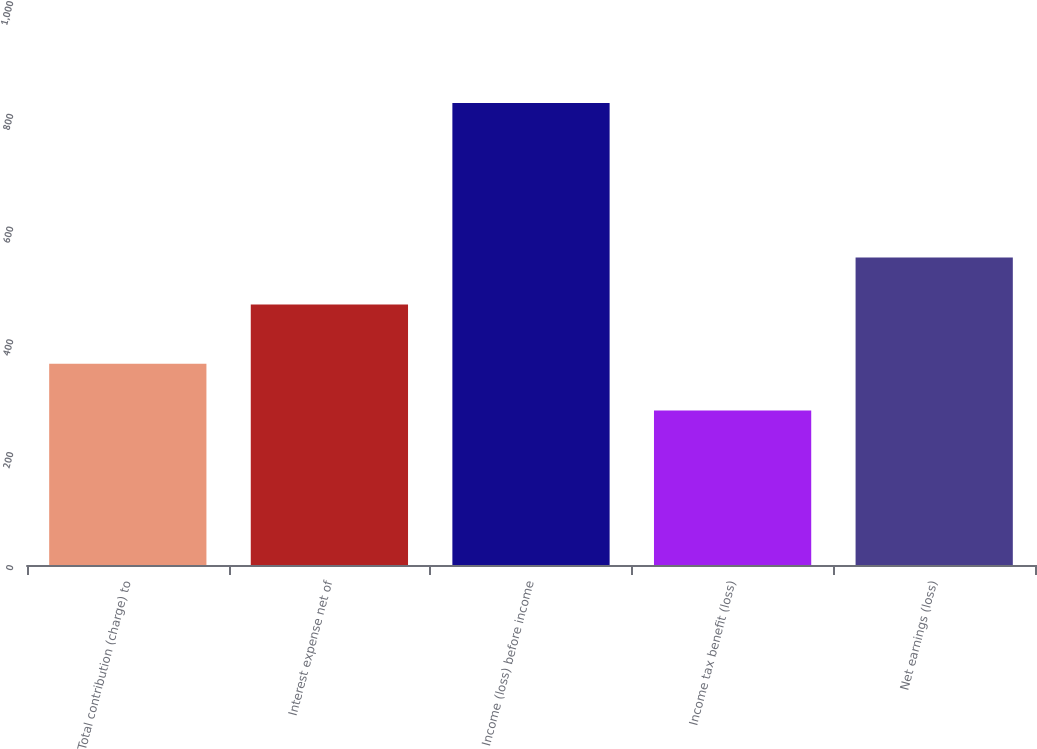Convert chart. <chart><loc_0><loc_0><loc_500><loc_500><bar_chart><fcel>Total contribution (charge) to<fcel>Interest expense net of<fcel>Income (loss) before income<fcel>Income tax benefit (loss)<fcel>Net earnings (loss)<nl><fcel>357<fcel>462<fcel>819<fcel>274<fcel>545<nl></chart> 